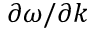Convert formula to latex. <formula><loc_0><loc_0><loc_500><loc_500>\partial \omega / \partial k</formula> 